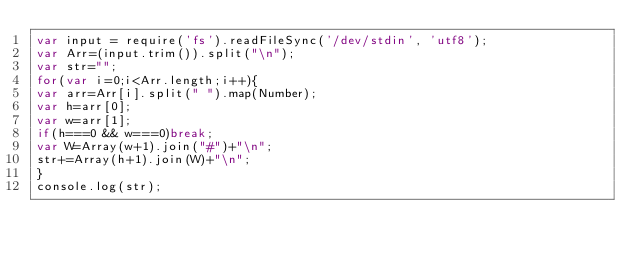Convert code to text. <code><loc_0><loc_0><loc_500><loc_500><_JavaScript_>var input = require('fs').readFileSync('/dev/stdin', 'utf8');
var Arr=(input.trim()).split("\n");
var str="";
for(var i=0;i<Arr.length;i++){
var arr=Arr[i].split(" ").map(Number);
var h=arr[0];
var w=arr[1];
if(h===0 && w===0)break;
var W=Array(w+1).join("#")+"\n";
str+=Array(h+1).join(W)+"\n";
}
console.log(str);</code> 